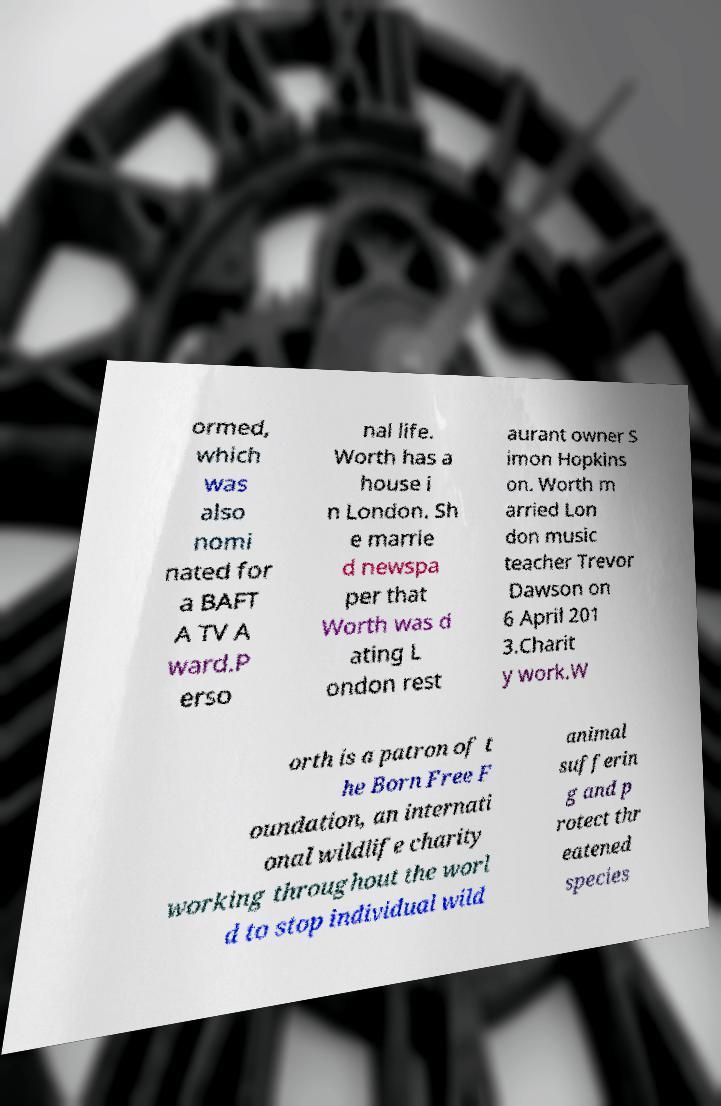What messages or text are displayed in this image? I need them in a readable, typed format. ormed, which was also nomi nated for a BAFT A TV A ward.P erso nal life. Worth has a house i n London. Sh e marrie d newspa per that Worth was d ating L ondon rest aurant owner S imon Hopkins on. Worth m arried Lon don music teacher Trevor Dawson on 6 April 201 3.Charit y work.W orth is a patron of t he Born Free F oundation, an internati onal wildlife charity working throughout the worl d to stop individual wild animal sufferin g and p rotect thr eatened species 